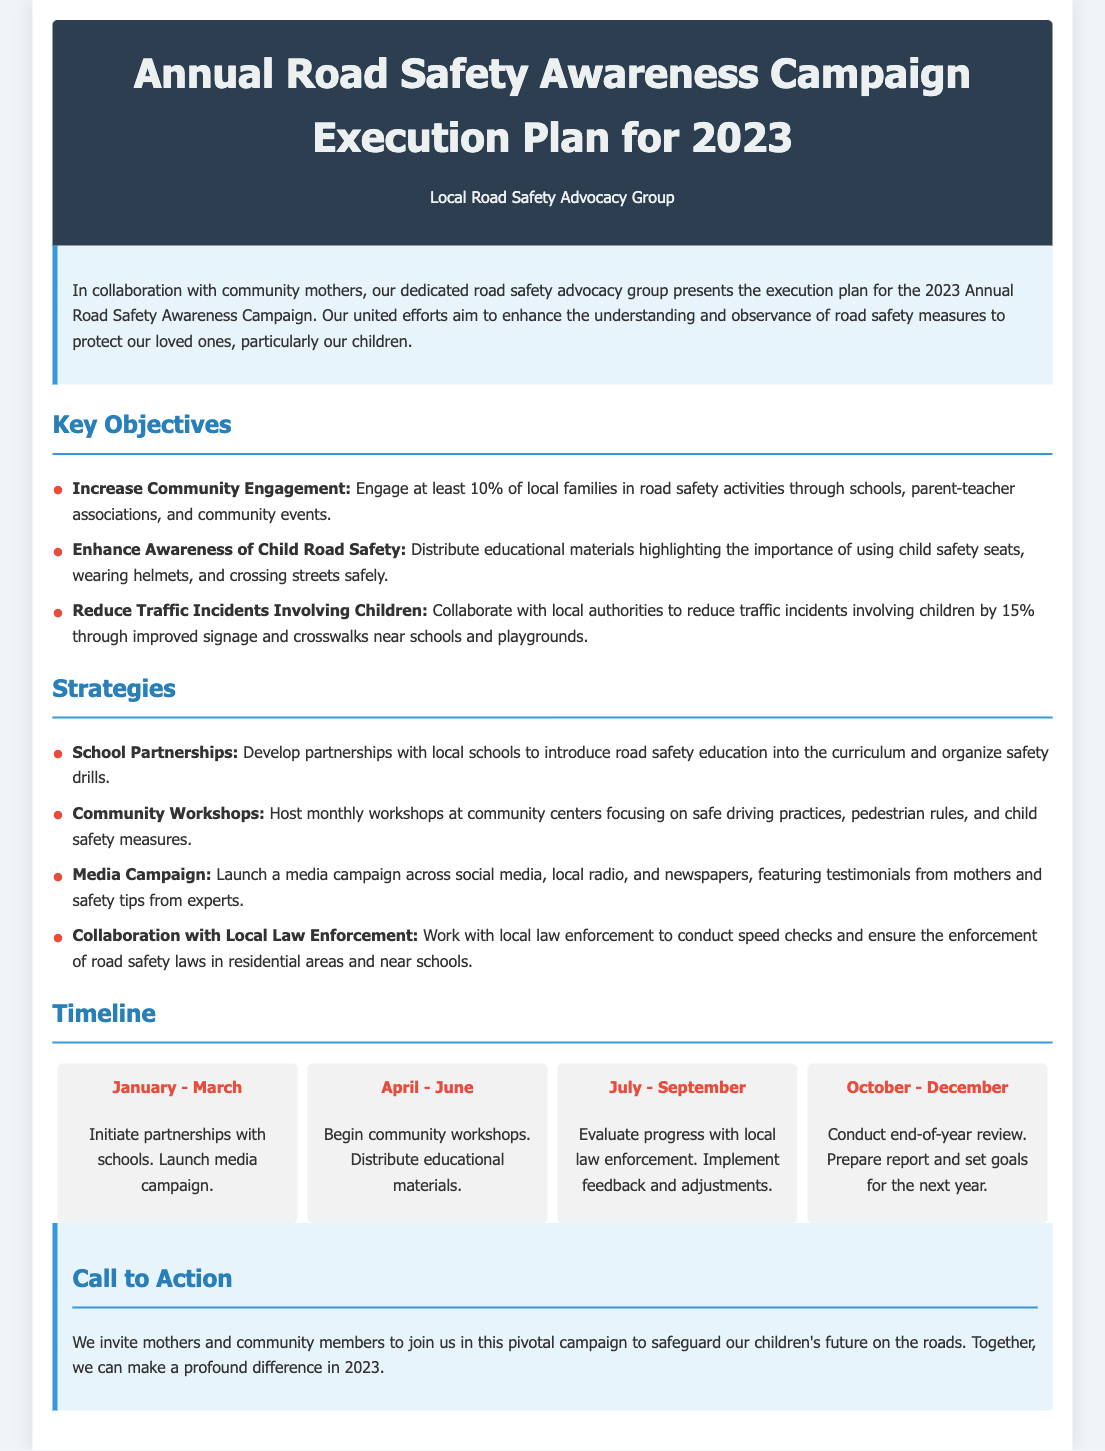What is the title of the document? The title is provided in the header of the document.
Answer: Annual Road Safety Awareness Campaign Execution Plan for 2023 What month does the campaign start? The timeline indicates the campaign begins in January.
Answer: January What is one of the key objectives of the campaign? The key objectives are listed in a section titled "Key Objectives."
Answer: Increase Community Engagement How much do we aim to reduce traffic incidents involving children? The document specifies the target reduction percentage for traffic incidents.
Answer: 15% What is the duration of the first phase of the timeline? The timeline outlines specific periods for each phase.
Answer: January - March Which strategy involves working with local law enforcement? Strategies are detailed in a specific section of the document.
Answer: Collaboration with Local Law Enforcement How many families does the campaign aim to engage? The objective discusses a specific percentage of local families.
Answer: 10% What activity is scheduled for April to June? The timeline lists activities for this period.
Answer: Begin community workshops What is the final step at the end of the year? The last part of the timeline provides details for the end of the year.
Answer: Conduct end-of-year review 